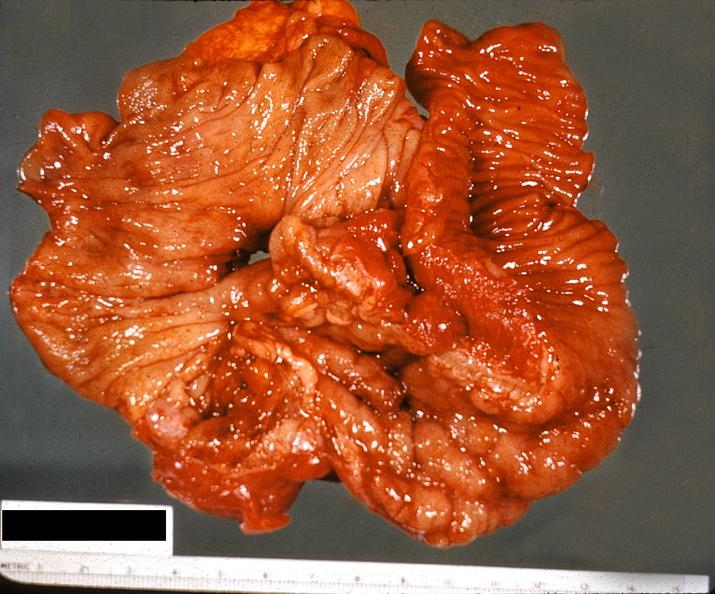what does this image show?
Answer the question using a single word or phrase. Ileum 